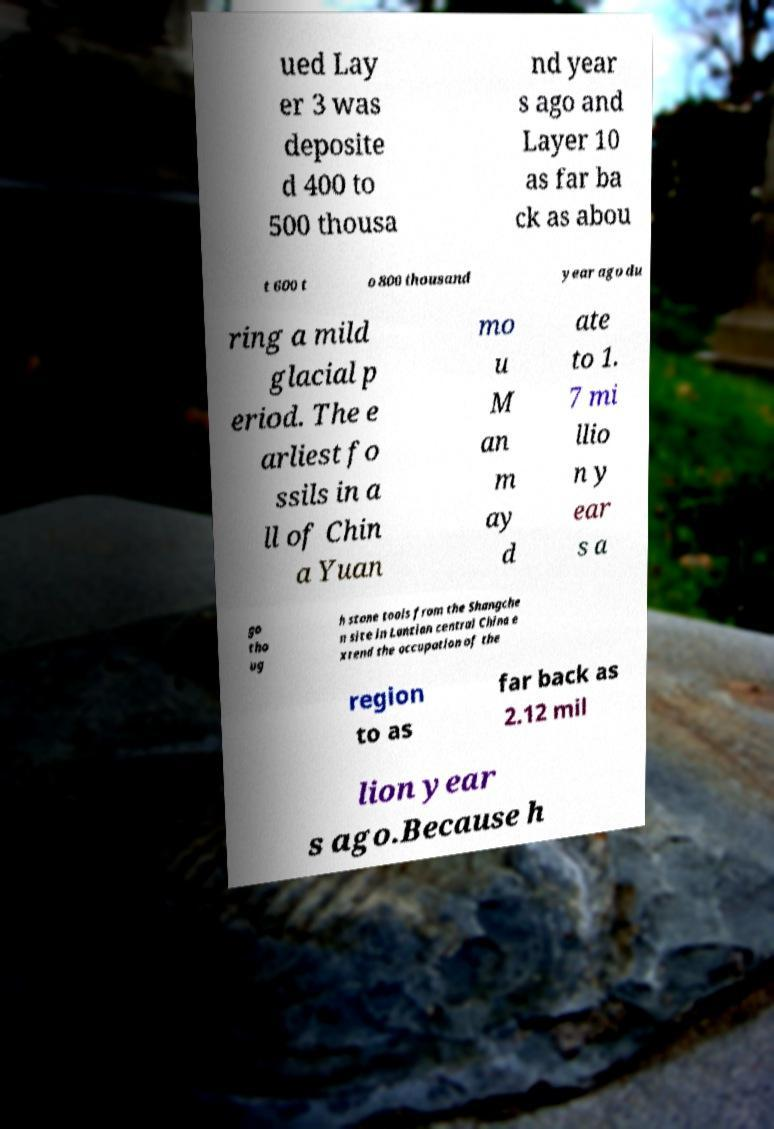Could you assist in decoding the text presented in this image and type it out clearly? ued Lay er 3 was deposite d 400 to 500 thousa nd year s ago and Layer 10 as far ba ck as abou t 600 t o 800 thousand year ago du ring a mild glacial p eriod. The e arliest fo ssils in a ll of Chin a Yuan mo u M an m ay d ate to 1. 7 mi llio n y ear s a go tho ug h stone tools from the Shangche n site in Lantian central China e xtend the occupation of the region to as far back as 2.12 mil lion year s ago.Because h 